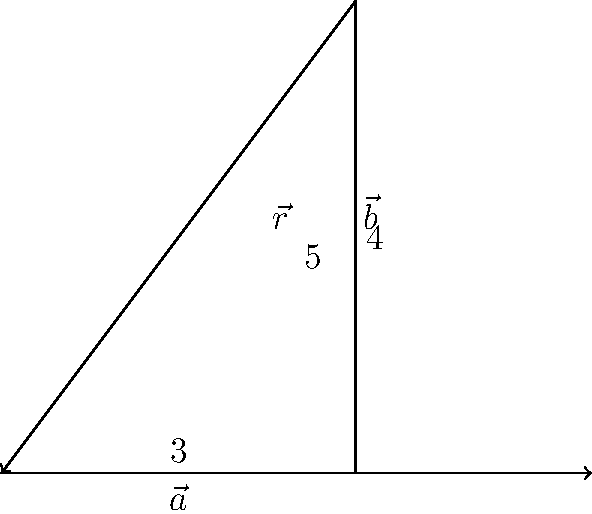Given two vectors $\vec{a}$ and $\vec{b}$ with magnitudes of 3 and 4 units respectively, forming a right angle as shown in the diagram. Calculate the magnitude of the resultant vector $\vec{r}$ after vector addition. To determine the magnitude of the resultant vector after vector addition, we can follow these steps:

1. Recognize that we have a right-angled triangle formed by vectors $\vec{a}$, $\vec{b}$, and the resultant $\vec{r}$.

2. Recall the Pythagorean theorem: In a right-angled triangle, the square of the hypotenuse (longest side) is equal to the sum of squares of the other two sides.

3. Let's denote the magnitude of the resultant vector as $|\vec{r}|$. According to the Pythagorean theorem:

   $$|\vec{r}|^2 = |\vec{a}|^2 + |\vec{b}|^2$$

4. Substitute the known values:
   $$|\vec{r}|^2 = 3^2 + 4^2$$

5. Calculate:
   $$|\vec{r}|^2 = 9 + 16 = 25$$

6. Take the square root of both sides:
   $$|\vec{r}| = \sqrt{25} = 5$$

Therefore, the magnitude of the resultant vector $\vec{r}$ is 5 units.
Answer: 5 units 